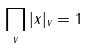Convert formula to latex. <formula><loc_0><loc_0><loc_500><loc_500>\prod _ { v } | x | _ { v } = 1</formula> 